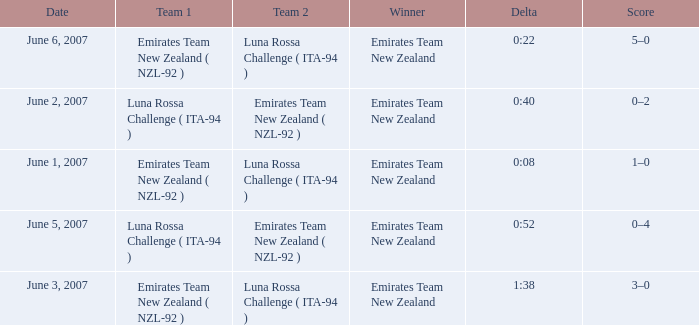On what Date is Delta 0:40? June 2, 2007. 